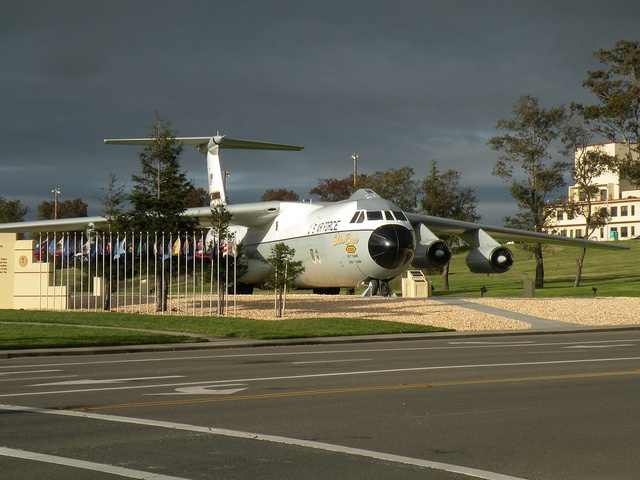Describe the objects in this image and their specific colors. I can see a airplane in purple, black, gray, ivory, and darkgreen tones in this image. 